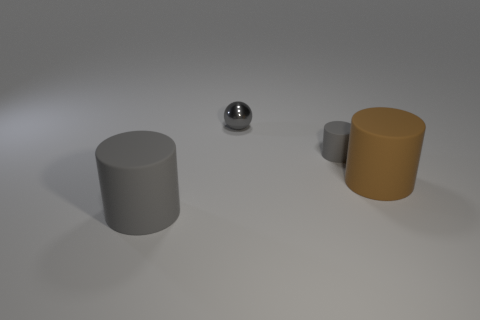The cylinder that is left of the matte thing that is behind the large cylinder that is on the right side of the tiny cylinder is made of what material?
Offer a very short reply. Rubber. What number of rubber things are either large cylinders or small cyan blocks?
Provide a short and direct response. 2. What number of yellow things are rubber things or large matte things?
Your answer should be very brief. 0. Does the large rubber cylinder to the right of the small gray metal thing have the same color as the metallic thing?
Give a very brief answer. No. Does the small sphere have the same material as the brown thing?
Your answer should be compact. No. Is the number of large brown cylinders that are behind the brown thing the same as the number of gray spheres right of the small gray metal sphere?
Make the answer very short. Yes. There is another gray object that is the same shape as the small matte thing; what material is it?
Offer a terse response. Rubber. What shape is the rubber thing to the right of the gray cylinder that is on the right side of the gray cylinder that is in front of the big brown cylinder?
Your answer should be very brief. Cylinder. Are there more big brown rubber objects behind the brown matte thing than small cylinders?
Provide a short and direct response. No. Is the shape of the big rubber thing to the right of the gray metallic thing the same as  the metallic object?
Keep it short and to the point. No. 